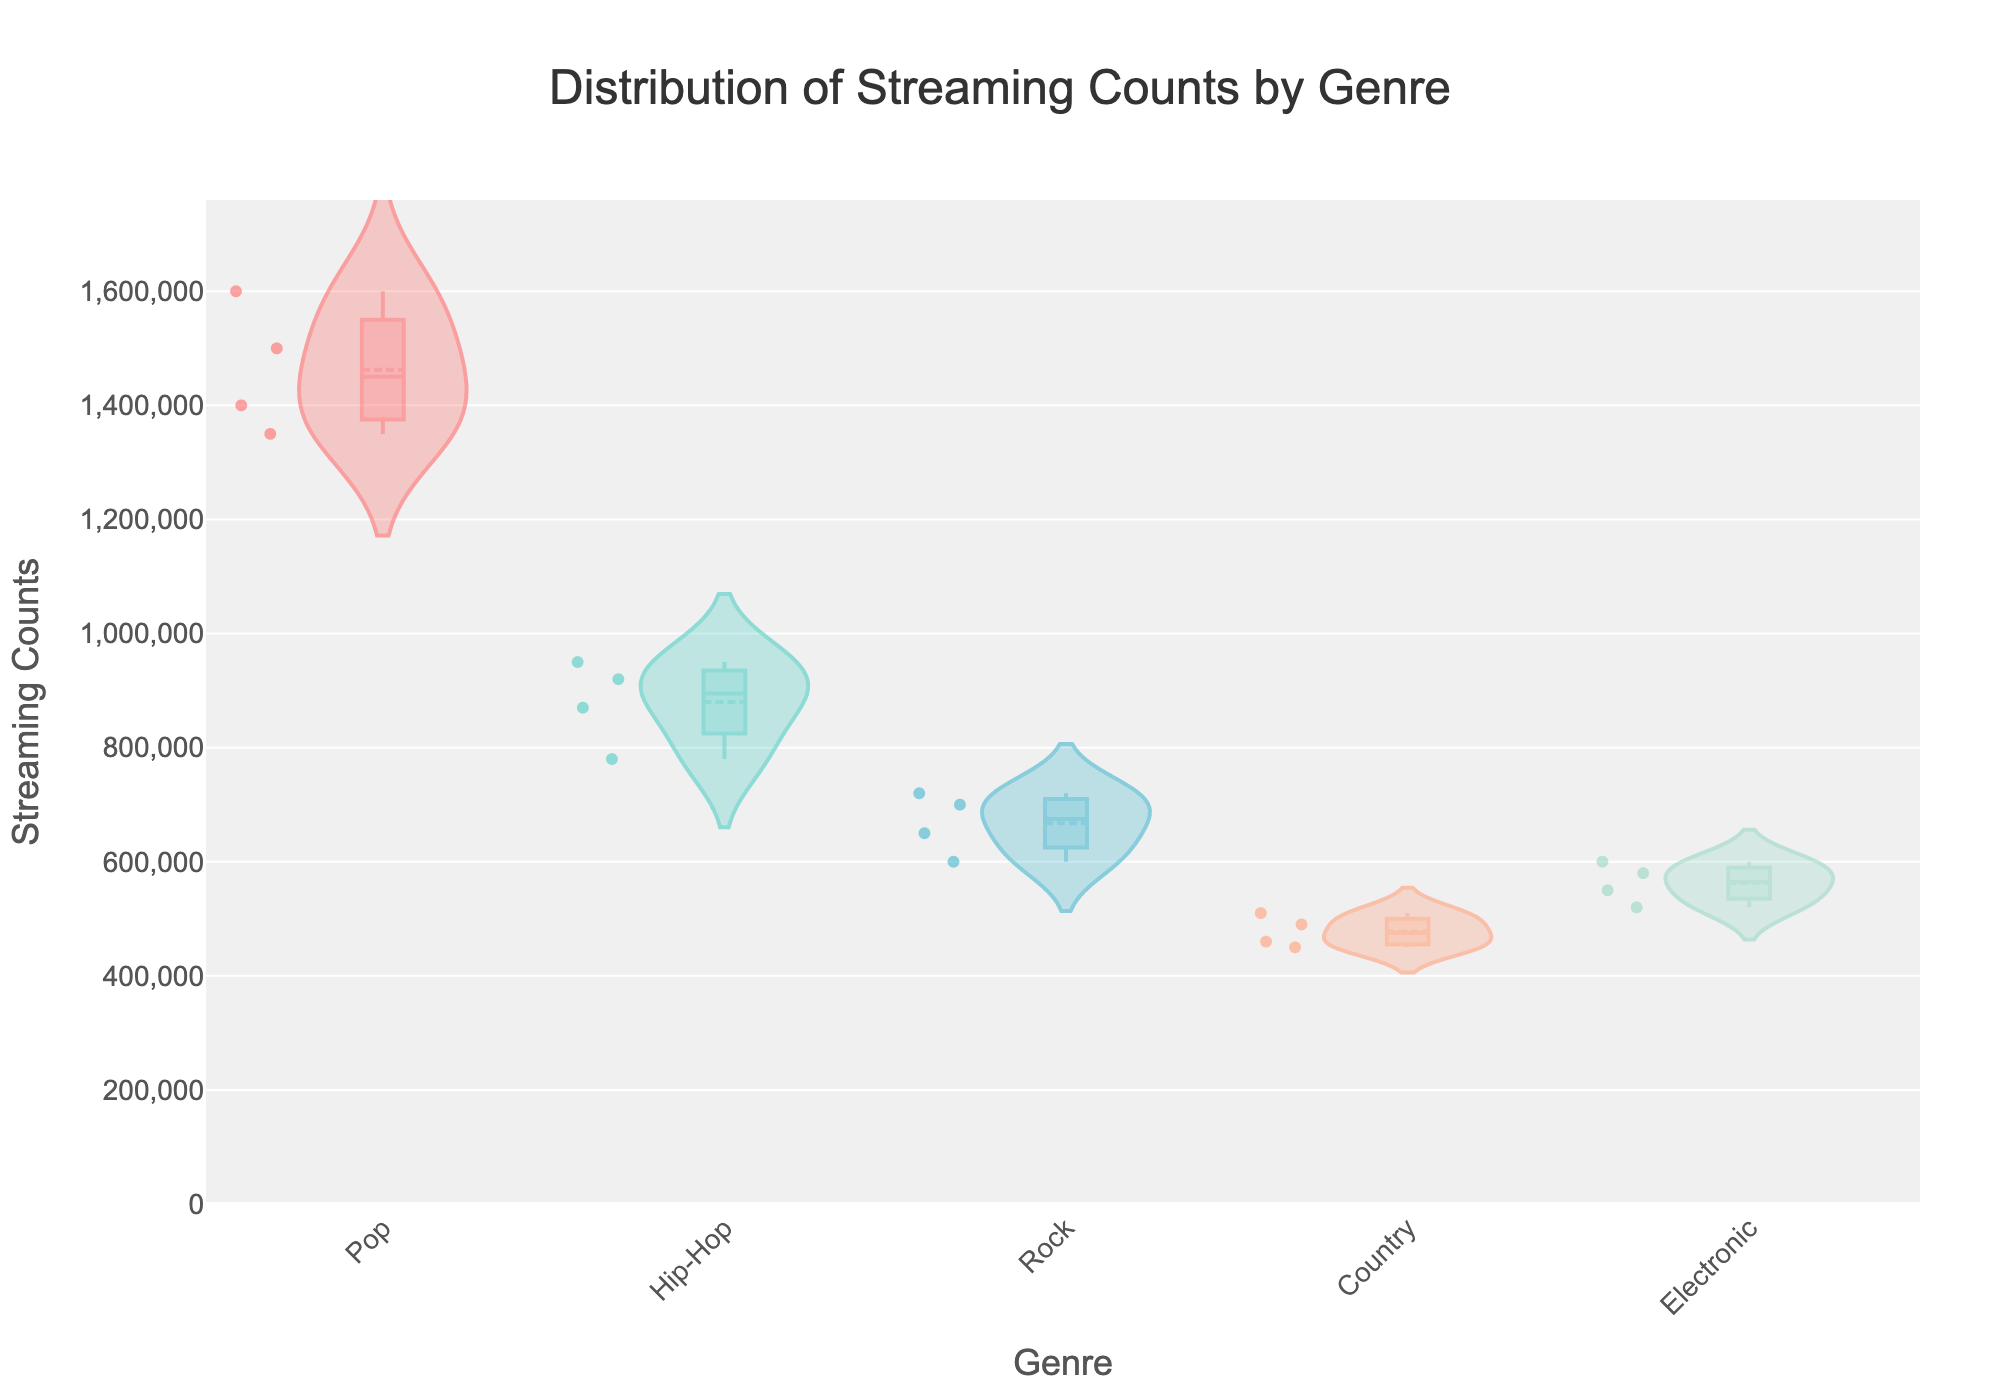what is the title of the figure? The title of the figure is located at the top center and is generally larger in font size compared to other text elements. It reads 'Distribution of Streaming Counts by Genre'.
Answer: Distribution of Streaming Counts by Genre Which genre has the highest maximum streaming counts? By looking at the figure, observing the maximum point of the violins representing each genre. The Pop genre reaches up to 1,600,000 streaming counts, which is the highest among all genres shown.
Answer: Pop What is the range of streaming counts for the Rock genre? The range is determined by looking at the minimum and maximum values of the streaming counts for the Rock genre. The lowest is around 600,000 and the highest is around 720,000. The range is thus 720,000 - 600,000 = 120,000.
Answer: 120,000 Which genre shows the smallest variation in streaming counts? The variation can be assessed by looking at the width and spread of the individual violins. The Rock genre has a narrow and small range that indicates the least variation compared to other genres.
Answer: Rock Which genre has the highest minimum streaming counts? The minimum count is the lowest streaming data point within each genre. The Pop genre's minimum is around 1,350,000, which is the highest minimum count compared to other genres’ minimums.
Answer: Pop Whats the average streaming count for the Hip-Hop tracks? To find the average, sum all streaming counts for the Hip-Hop genre and divide the total by the number of tracks. (920,000 + 870,000 + 950,000 + 780,000) sum to 3,520,000. Dividing by 4 tracks gives an average of 880,000.
Answer: 880,000 Are there any outliers in the data, and if so, which genre displays them? Outliers are typically shown as separate points away from the main body of the violin plot. The Hip-Hop genre shows a lower point around 780,000 counts that can be considered an outlier compared to its main distribution.
Answer: Hip-Hop How does the Pop genre streaming count distribution compare to the Electronic genre? Compare the spread and central tendencies of the two genres' violins. The Pop genre shows a greater spread and higher central value whereas the Electronic genre has a narrower spread centered around lower values.
Answer: Pop has a greater spread and higher central value Which genre has the most consistent number of streams across the tracks? Consistency can be determined by checking which genre has the smallest spread and least deviation from the mean. The Rock genre has a closely packed distribution indicating consistent number of streams.
Answer: Rock 